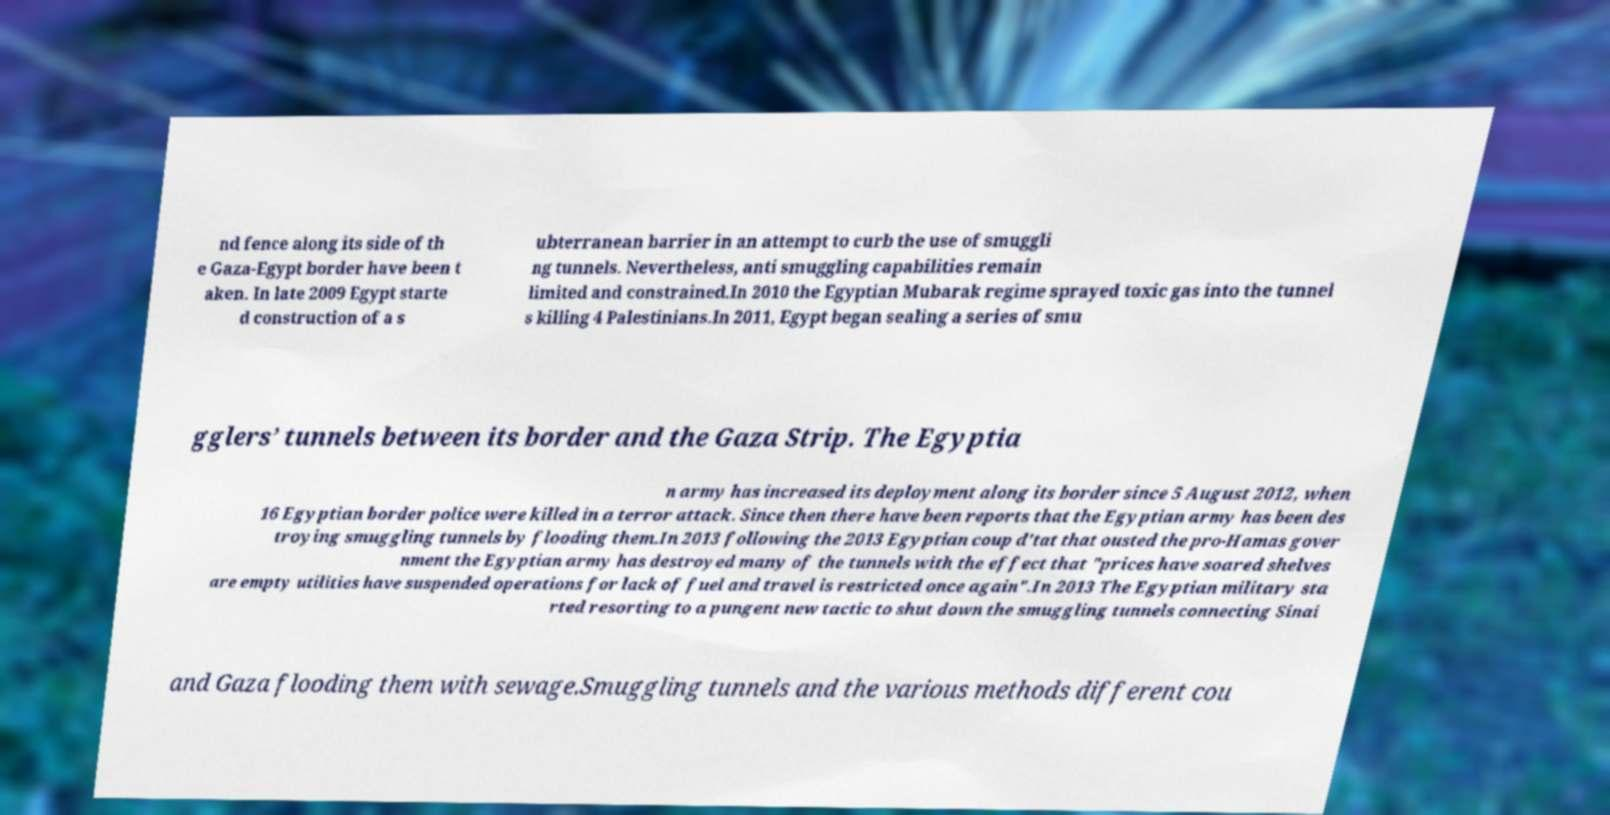Can you read and provide the text displayed in the image?This photo seems to have some interesting text. Can you extract and type it out for me? nd fence along its side of th e Gaza-Egypt border have been t aken. In late 2009 Egypt starte d construction of a s ubterranean barrier in an attempt to curb the use of smuggli ng tunnels. Nevertheless, anti smuggling capabilities remain limited and constrained.In 2010 the Egyptian Mubarak regime sprayed toxic gas into the tunnel s killing 4 Palestinians.In 2011, Egypt began sealing a series of smu gglers’ tunnels between its border and the Gaza Strip. The Egyptia n army has increased its deployment along its border since 5 August 2012, when 16 Egyptian border police were killed in a terror attack. Since then there have been reports that the Egyptian army has been des troying smuggling tunnels by flooding them.In 2013 following the 2013 Egyptian coup d'tat that ousted the pro-Hamas gover nment the Egyptian army has destroyed many of the tunnels with the effect that "prices have soared shelves are empty utilities have suspended operations for lack of fuel and travel is restricted once again".In 2013 The Egyptian military sta rted resorting to a pungent new tactic to shut down the smuggling tunnels connecting Sinai and Gaza flooding them with sewage.Smuggling tunnels and the various methods different cou 